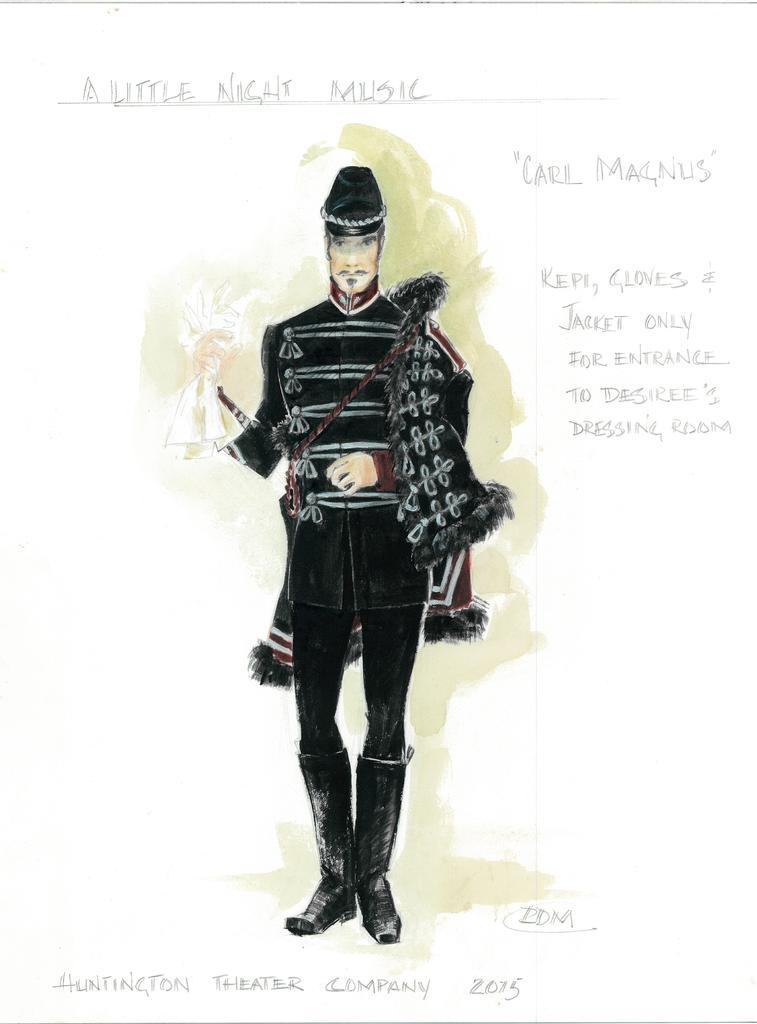What is the main subject of the image? There is a person standing in the image. What is the person wearing? The person is wearing a black dress. What else can be seen in the image besides the person? There is text or writing visible in the image. What month is it in the image? There is no indication of a specific month in the image. Can you describe how the person is stretching in the image? The person is not stretching in the image; they are standing still. 